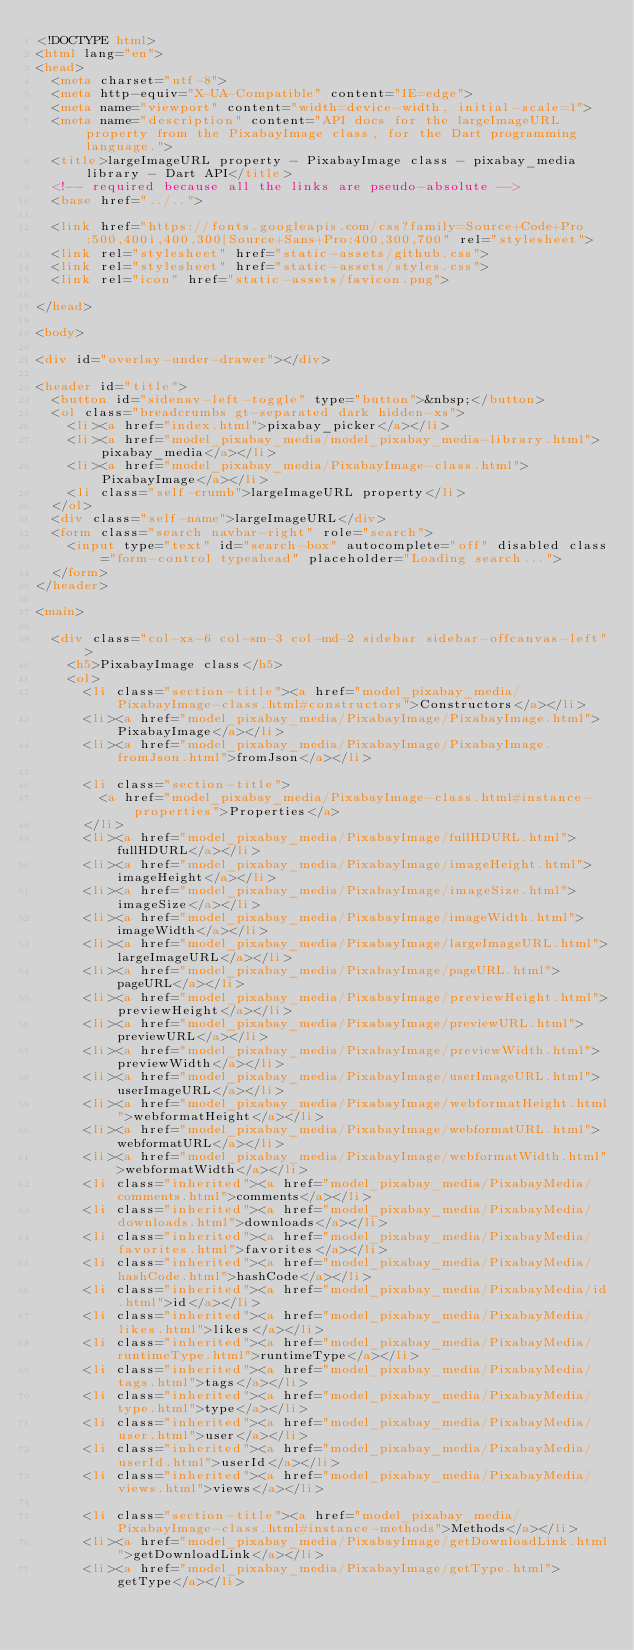<code> <loc_0><loc_0><loc_500><loc_500><_HTML_><!DOCTYPE html>
<html lang="en">
<head>
  <meta charset="utf-8">
  <meta http-equiv="X-UA-Compatible" content="IE=edge">
  <meta name="viewport" content="width=device-width, initial-scale=1">
  <meta name="description" content="API docs for the largeImageURL property from the PixabayImage class, for the Dart programming language.">
  <title>largeImageURL property - PixabayImage class - pixabay_media library - Dart API</title>
  <!-- required because all the links are pseudo-absolute -->
  <base href="../..">

  <link href="https://fonts.googleapis.com/css?family=Source+Code+Pro:500,400i,400,300|Source+Sans+Pro:400,300,700" rel="stylesheet">
  <link rel="stylesheet" href="static-assets/github.css">
  <link rel="stylesheet" href="static-assets/styles.css">
  <link rel="icon" href="static-assets/favicon.png">

</head>

<body>

<div id="overlay-under-drawer"></div>

<header id="title">
  <button id="sidenav-left-toggle" type="button">&nbsp;</button>
  <ol class="breadcrumbs gt-separated dark hidden-xs">
    <li><a href="index.html">pixabay_picker</a></li>
    <li><a href="model_pixabay_media/model_pixabay_media-library.html">pixabay_media</a></li>
    <li><a href="model_pixabay_media/PixabayImage-class.html">PixabayImage</a></li>
    <li class="self-crumb">largeImageURL property</li>
  </ol>
  <div class="self-name">largeImageURL</div>
  <form class="search navbar-right" role="search">
    <input type="text" id="search-box" autocomplete="off" disabled class="form-control typeahead" placeholder="Loading search...">
  </form>
</header>

<main>

  <div class="col-xs-6 col-sm-3 col-md-2 sidebar sidebar-offcanvas-left">
    <h5>PixabayImage class</h5>
    <ol>
      <li class="section-title"><a href="model_pixabay_media/PixabayImage-class.html#constructors">Constructors</a></li>
      <li><a href="model_pixabay_media/PixabayImage/PixabayImage.html">PixabayImage</a></li>
      <li><a href="model_pixabay_media/PixabayImage/PixabayImage.fromJson.html">fromJson</a></li>
    
      <li class="section-title">
        <a href="model_pixabay_media/PixabayImage-class.html#instance-properties">Properties</a>
      </li>
      <li><a href="model_pixabay_media/PixabayImage/fullHDURL.html">fullHDURL</a></li>
      <li><a href="model_pixabay_media/PixabayImage/imageHeight.html">imageHeight</a></li>
      <li><a href="model_pixabay_media/PixabayImage/imageSize.html">imageSize</a></li>
      <li><a href="model_pixabay_media/PixabayImage/imageWidth.html">imageWidth</a></li>
      <li><a href="model_pixabay_media/PixabayImage/largeImageURL.html">largeImageURL</a></li>
      <li><a href="model_pixabay_media/PixabayImage/pageURL.html">pageURL</a></li>
      <li><a href="model_pixabay_media/PixabayImage/previewHeight.html">previewHeight</a></li>
      <li><a href="model_pixabay_media/PixabayImage/previewURL.html">previewURL</a></li>
      <li><a href="model_pixabay_media/PixabayImage/previewWidth.html">previewWidth</a></li>
      <li><a href="model_pixabay_media/PixabayImage/userImageURL.html">userImageURL</a></li>
      <li><a href="model_pixabay_media/PixabayImage/webformatHeight.html">webformatHeight</a></li>
      <li><a href="model_pixabay_media/PixabayImage/webformatURL.html">webformatURL</a></li>
      <li><a href="model_pixabay_media/PixabayImage/webformatWidth.html">webformatWidth</a></li>
      <li class="inherited"><a href="model_pixabay_media/PixabayMedia/comments.html">comments</a></li>
      <li class="inherited"><a href="model_pixabay_media/PixabayMedia/downloads.html">downloads</a></li>
      <li class="inherited"><a href="model_pixabay_media/PixabayMedia/favorites.html">favorites</a></li>
      <li class="inherited"><a href="model_pixabay_media/PixabayMedia/hashCode.html">hashCode</a></li>
      <li class="inherited"><a href="model_pixabay_media/PixabayMedia/id.html">id</a></li>
      <li class="inherited"><a href="model_pixabay_media/PixabayMedia/likes.html">likes</a></li>
      <li class="inherited"><a href="model_pixabay_media/PixabayMedia/runtimeType.html">runtimeType</a></li>
      <li class="inherited"><a href="model_pixabay_media/PixabayMedia/tags.html">tags</a></li>
      <li class="inherited"><a href="model_pixabay_media/PixabayMedia/type.html">type</a></li>
      <li class="inherited"><a href="model_pixabay_media/PixabayMedia/user.html">user</a></li>
      <li class="inherited"><a href="model_pixabay_media/PixabayMedia/userId.html">userId</a></li>
      <li class="inherited"><a href="model_pixabay_media/PixabayMedia/views.html">views</a></li>
    
      <li class="section-title"><a href="model_pixabay_media/PixabayImage-class.html#instance-methods">Methods</a></li>
      <li><a href="model_pixabay_media/PixabayImage/getDownloadLink.html">getDownloadLink</a></li>
      <li><a href="model_pixabay_media/PixabayImage/getType.html">getType</a></li></code> 